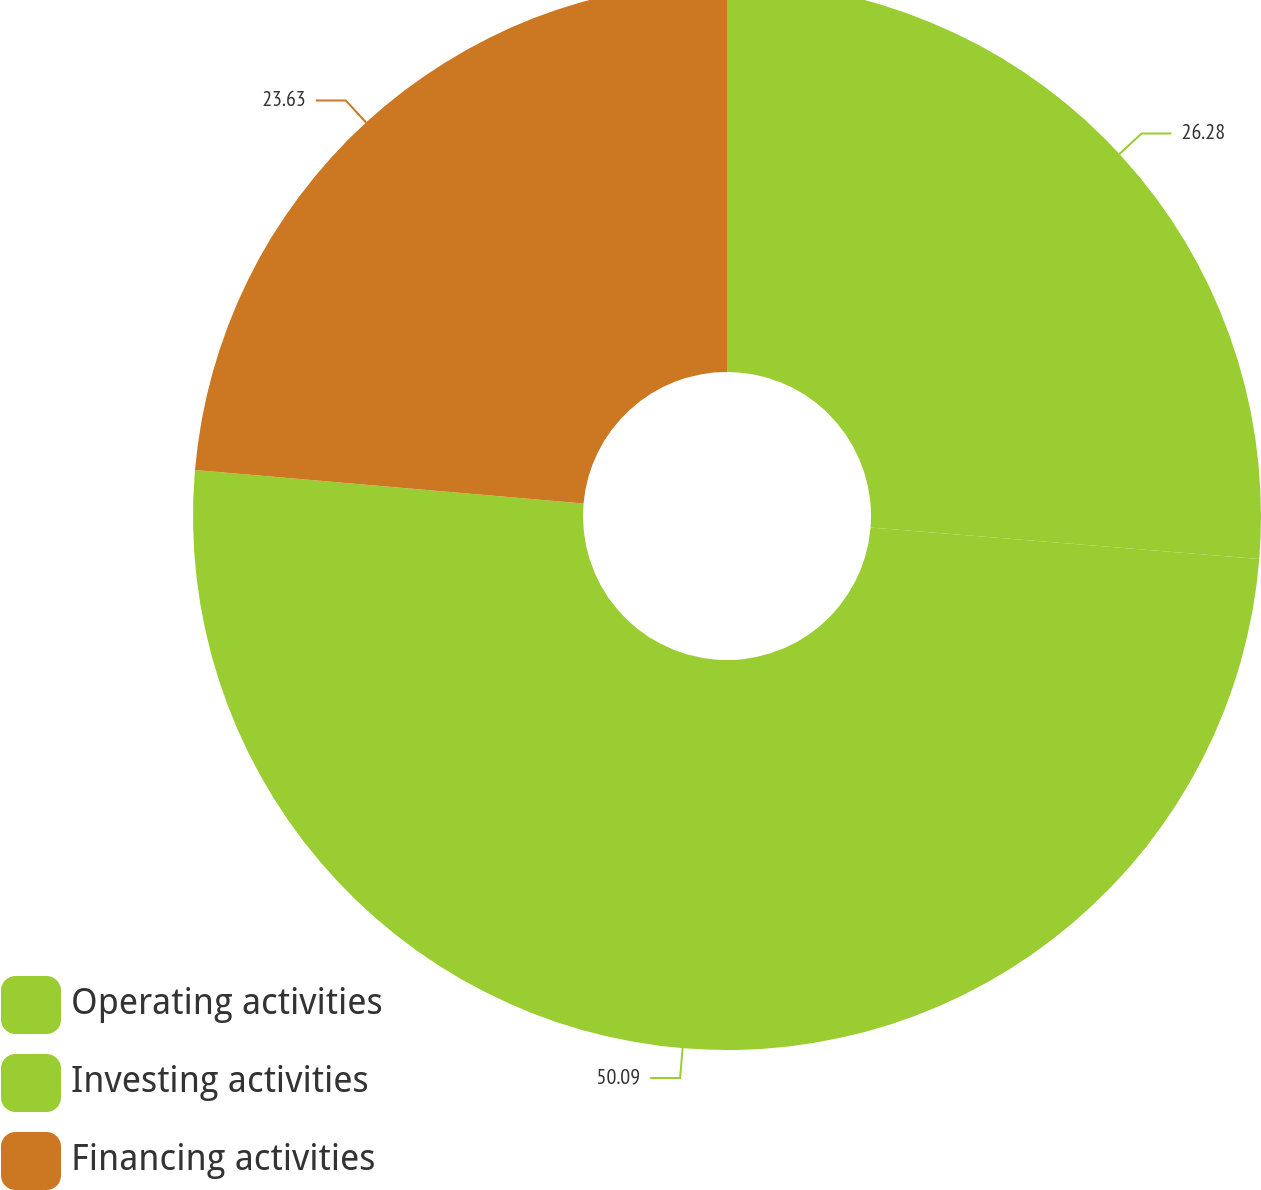<chart> <loc_0><loc_0><loc_500><loc_500><pie_chart><fcel>Operating activities<fcel>Investing activities<fcel>Financing activities<nl><fcel>26.28%<fcel>50.09%<fcel>23.63%<nl></chart> 